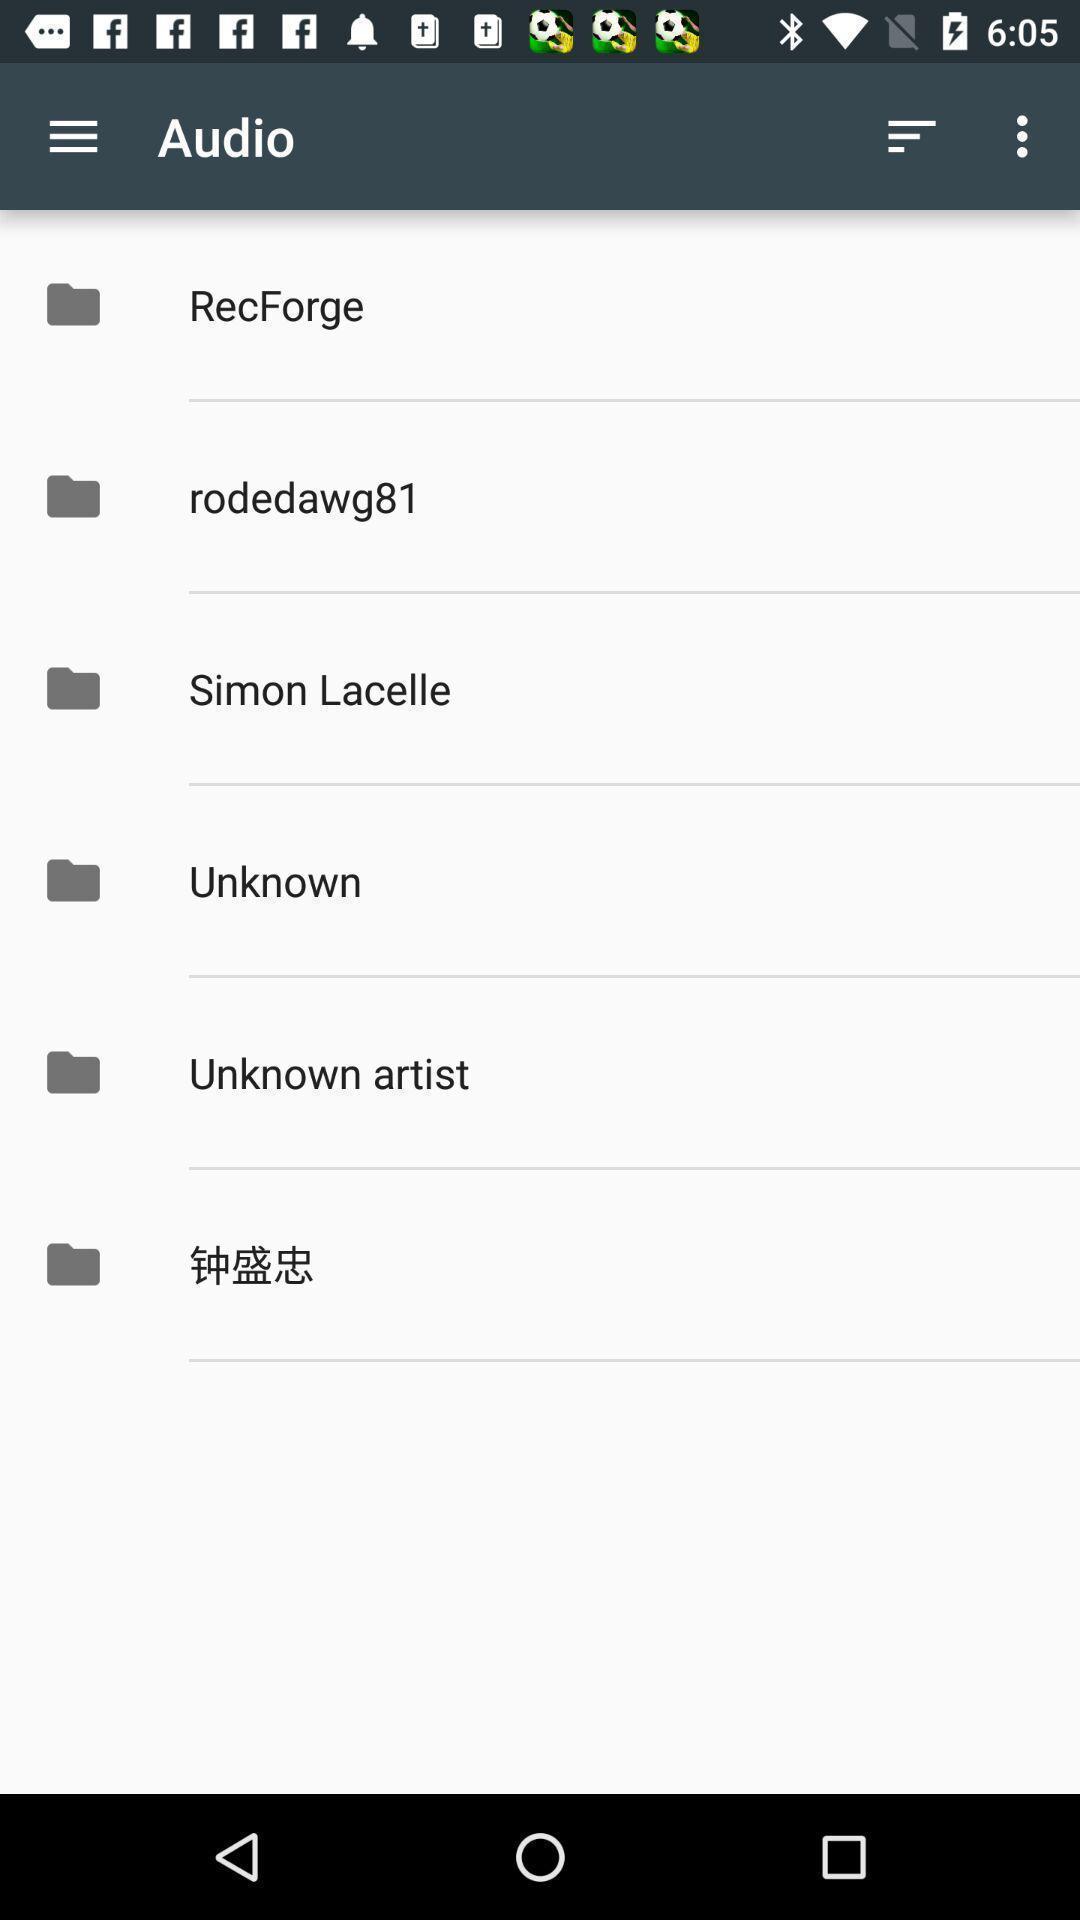Provide a description of this screenshot. Screen shows multiple options. 